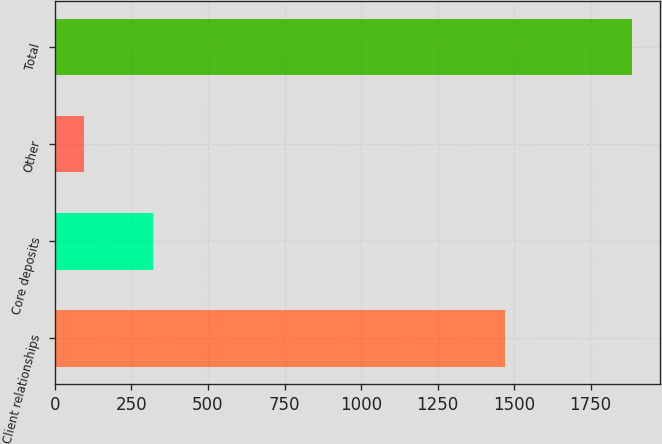<chart> <loc_0><loc_0><loc_500><loc_500><bar_chart><fcel>Client relationships<fcel>Core deposits<fcel>Other<fcel>Total<nl><fcel>1470<fcel>320<fcel>94<fcel>1884<nl></chart> 